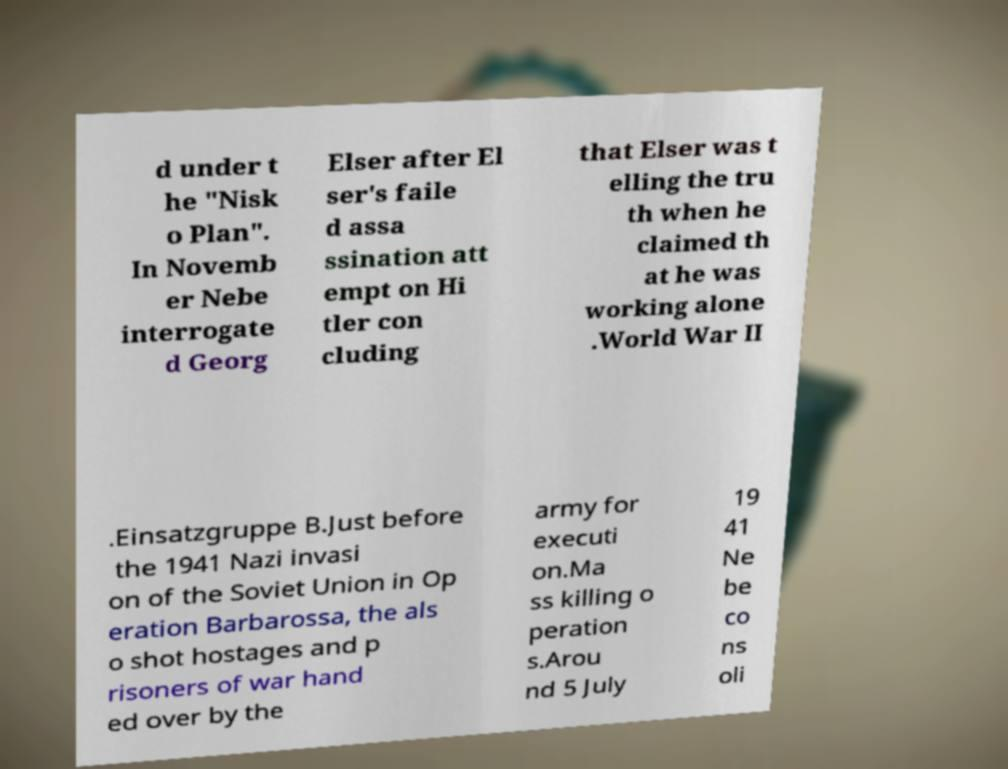I need the written content from this picture converted into text. Can you do that? d under t he "Nisk o Plan". In Novemb er Nebe interrogate d Georg Elser after El ser's faile d assa ssination att empt on Hi tler con cluding that Elser was t elling the tru th when he claimed th at he was working alone .World War II .Einsatzgruppe B.Just before the 1941 Nazi invasi on of the Soviet Union in Op eration Barbarossa, the als o shot hostages and p risoners of war hand ed over by the army for executi on.Ma ss killing o peration s.Arou nd 5 July 19 41 Ne be co ns oli 